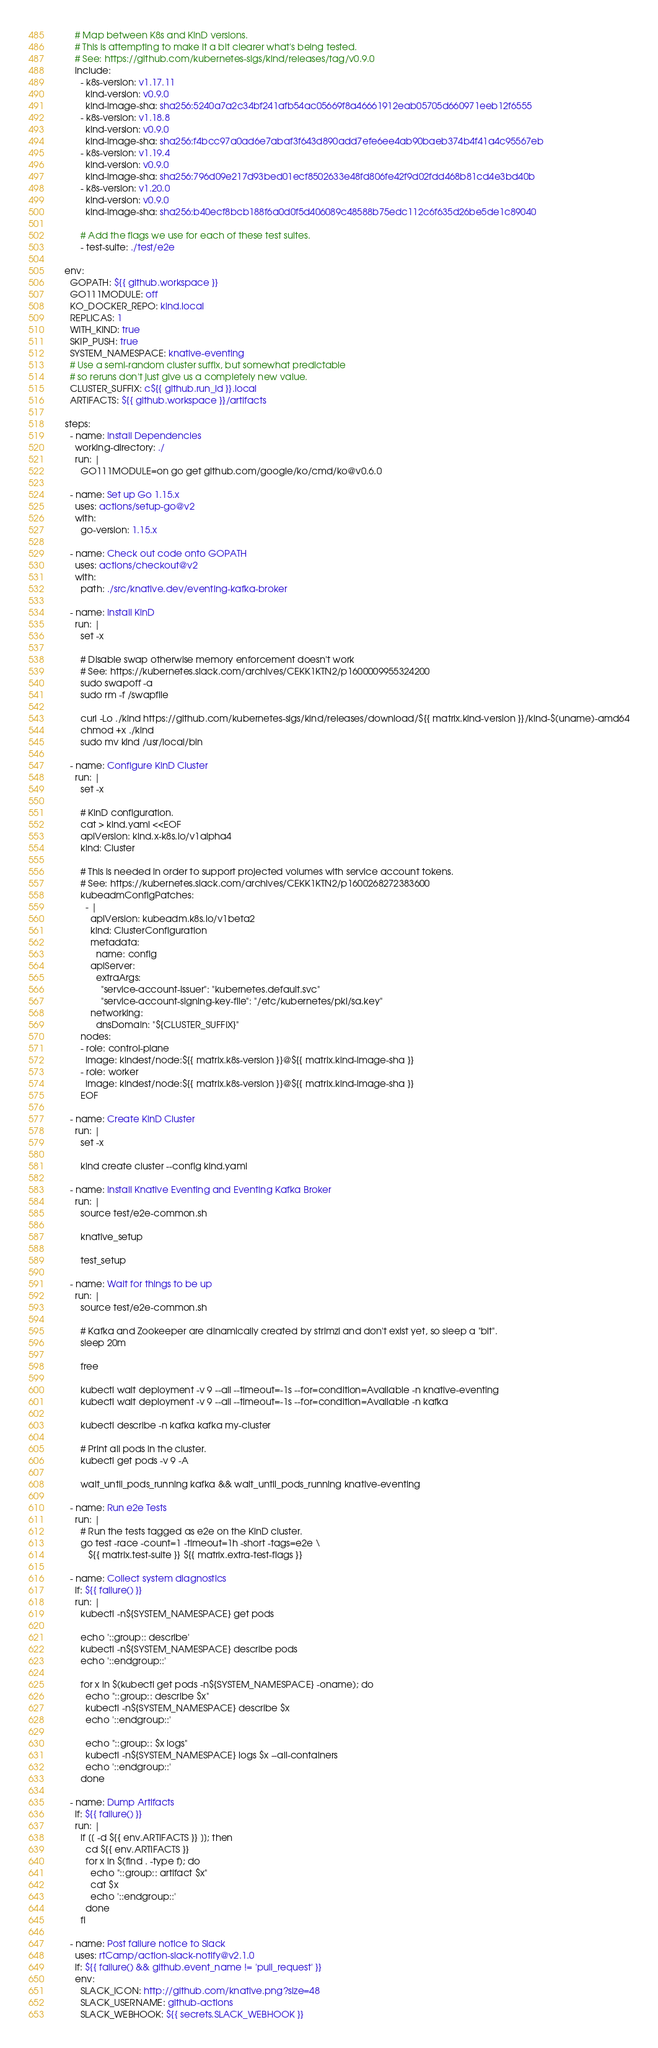<code> <loc_0><loc_0><loc_500><loc_500><_YAML_>
        # Map between K8s and KinD versions.
        # This is attempting to make it a bit clearer what's being tested.
        # See: https://github.com/kubernetes-sigs/kind/releases/tag/v0.9.0
        include:
          - k8s-version: v1.17.11
            kind-version: v0.9.0
            kind-image-sha: sha256:5240a7a2c34bf241afb54ac05669f8a46661912eab05705d660971eeb12f6555
          - k8s-version: v1.18.8
            kind-version: v0.9.0
            kind-image-sha: sha256:f4bcc97a0ad6e7abaf3f643d890add7efe6ee4ab90baeb374b4f41a4c95567eb
          - k8s-version: v1.19.4
            kind-version: v0.9.0
            kind-image-sha: sha256:796d09e217d93bed01ecf8502633e48fd806fe42f9d02fdd468b81cd4e3bd40b
          - k8s-version: v1.20.0
            kind-version: v0.9.0
            kind-image-sha: sha256:b40ecf8bcb188f6a0d0f5d406089c48588b75edc112c6f635d26be5de1c89040

          # Add the flags we use for each of these test suites.
          - test-suite: ./test/e2e

    env:
      GOPATH: ${{ github.workspace }}
      GO111MODULE: off
      KO_DOCKER_REPO: kind.local
      REPLICAS: 1
      WITH_KIND: true
      SKIP_PUSH: true
      SYSTEM_NAMESPACE: knative-eventing
      # Use a semi-random cluster suffix, but somewhat predictable
      # so reruns don't just give us a completely new value.
      CLUSTER_SUFFIX: c${{ github.run_id }}.local
      ARTIFACTS: ${{ github.workspace }}/artifacts

    steps:
      - name: Install Dependencies
        working-directory: ./
        run: |
          GO111MODULE=on go get github.com/google/ko/cmd/ko@v0.6.0

      - name: Set up Go 1.15.x
        uses: actions/setup-go@v2
        with:
          go-version: 1.15.x

      - name: Check out code onto GOPATH
        uses: actions/checkout@v2
        with:
          path: ./src/knative.dev/eventing-kafka-broker

      - name: Install KinD
        run: |
          set -x

          # Disable swap otherwise memory enforcement doesn't work
          # See: https://kubernetes.slack.com/archives/CEKK1KTN2/p1600009955324200
          sudo swapoff -a
          sudo rm -f /swapfile

          curl -Lo ./kind https://github.com/kubernetes-sigs/kind/releases/download/${{ matrix.kind-version }}/kind-$(uname)-amd64
          chmod +x ./kind
          sudo mv kind /usr/local/bin

      - name: Configure KinD Cluster
        run: |
          set -x

          # KinD configuration.
          cat > kind.yaml <<EOF
          apiVersion: kind.x-k8s.io/v1alpha4
          kind: Cluster

          # This is needed in order to support projected volumes with service account tokens.
          # See: https://kubernetes.slack.com/archives/CEKK1KTN2/p1600268272383600
          kubeadmConfigPatches:
            - |
              apiVersion: kubeadm.k8s.io/v1beta2
              kind: ClusterConfiguration
              metadata:
                name: config
              apiServer:
                extraArgs:
                  "service-account-issuer": "kubernetes.default.svc"
                  "service-account-signing-key-file": "/etc/kubernetes/pki/sa.key"
              networking:
                dnsDomain: "${CLUSTER_SUFFIX}"
          nodes:
          - role: control-plane
            image: kindest/node:${{ matrix.k8s-version }}@${{ matrix.kind-image-sha }}
          - role: worker
            image: kindest/node:${{ matrix.k8s-version }}@${{ matrix.kind-image-sha }}
          EOF

      - name: Create KinD Cluster
        run: |
          set -x

          kind create cluster --config kind.yaml

      - name: Install Knative Eventing and Eventing Kafka Broker
        run: |
          source test/e2e-common.sh

          knative_setup

          test_setup

      - name: Wait for things to be up
        run: |
          source test/e2e-common.sh

          # Kafka and Zookeeper are dinamically created by strimzi and don't exist yet, so sleep a "bit".
          sleep 20m

          free

          kubectl wait deployment -v 9 --all --timeout=-1s --for=condition=Available -n knative-eventing
          kubectl wait deployment -v 9 --all --timeout=-1s --for=condition=Available -n kafka

          kubectl describe -n kafka kafka my-cluster

          # Print all pods in the cluster.
          kubectl get pods -v 9 -A

          wait_until_pods_running kafka && wait_until_pods_running knative-eventing

      - name: Run e2e Tests
        run: |
          # Run the tests tagged as e2e on the KinD cluster.
          go test -race -count=1 -timeout=1h -short -tags=e2e \
             ${{ matrix.test-suite }} ${{ matrix.extra-test-flags }}

      - name: Collect system diagnostics
        if: ${{ failure() }}
        run: |
          kubectl -n${SYSTEM_NAMESPACE} get pods

          echo '::group:: describe'
          kubectl -n${SYSTEM_NAMESPACE} describe pods
          echo '::endgroup::'

          for x in $(kubectl get pods -n${SYSTEM_NAMESPACE} -oname); do
            echo "::group:: describe $x"
            kubectl -n${SYSTEM_NAMESPACE} describe $x
            echo '::endgroup::'

            echo "::group:: $x logs"
            kubectl -n${SYSTEM_NAMESPACE} logs $x --all-containers
            echo '::endgroup::'
          done

      - name: Dump Artifacts
        if: ${{ failure() }}
        run: |
          if [[ -d ${{ env.ARTIFACTS }} ]]; then
            cd ${{ env.ARTIFACTS }}
            for x in $(find . -type f); do
              echo "::group:: artifact $x"
              cat $x
              echo '::endgroup::'
            done
          fi

      - name: Post failure notice to Slack
        uses: rtCamp/action-slack-notify@v2.1.0
        if: ${{ failure() && github.event_name != 'pull_request' }}
        env:
          SLACK_ICON: http://github.com/knative.png?size=48
          SLACK_USERNAME: github-actions
          SLACK_WEBHOOK: ${{ secrets.SLACK_WEBHOOK }}
</code> 